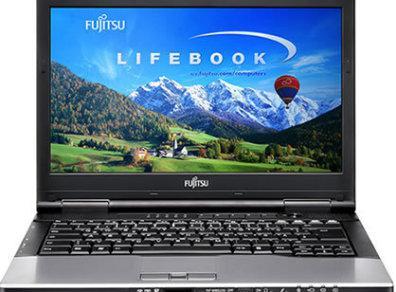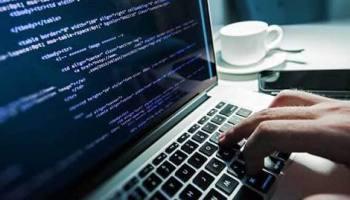The first image is the image on the left, the second image is the image on the right. Given the left and right images, does the statement "In 1 of the images, 2 hands are typing." hold true? Answer yes or no. No. The first image is the image on the left, the second image is the image on the right. Examine the images to the left and right. Is the description "A light source is attached to a laptop" accurate? Answer yes or no. No. 